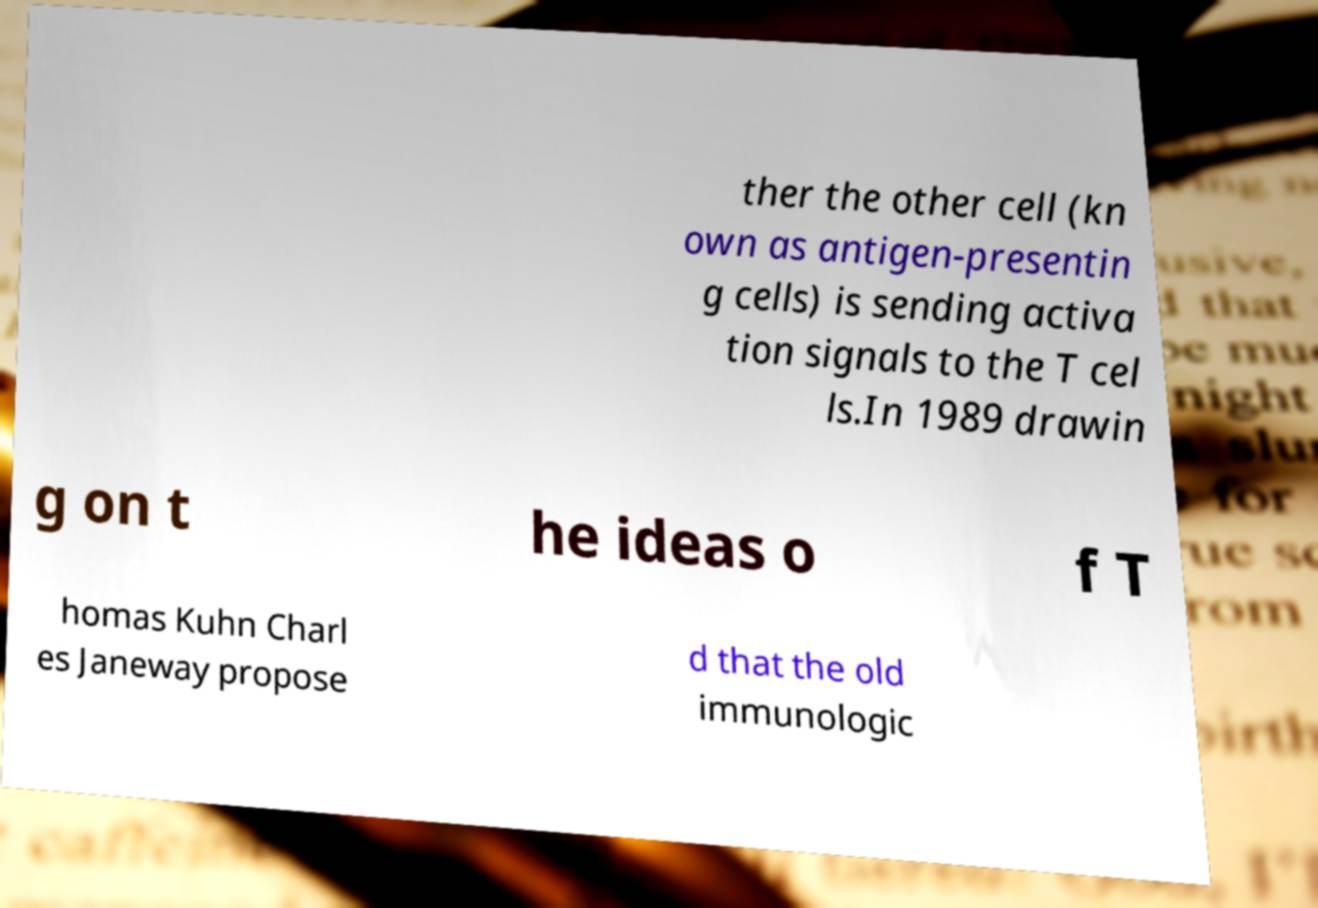Please identify and transcribe the text found in this image. ther the other cell (kn own as antigen-presentin g cells) is sending activa tion signals to the T cel ls.In 1989 drawin g on t he ideas o f T homas Kuhn Charl es Janeway propose d that the old immunologic 